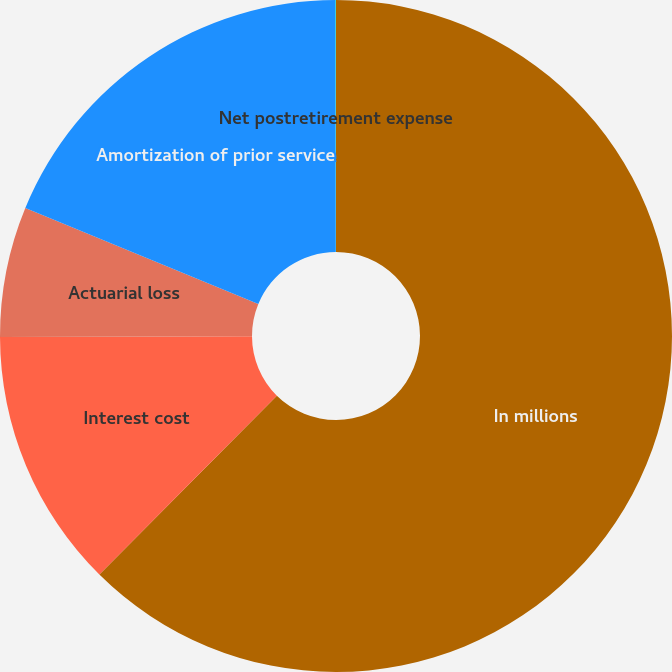Convert chart. <chart><loc_0><loc_0><loc_500><loc_500><pie_chart><fcel>In millions<fcel>Interest cost<fcel>Actuarial loss<fcel>Amortization of prior service<fcel>Net postretirement expense<nl><fcel>62.43%<fcel>12.51%<fcel>6.27%<fcel>18.75%<fcel>0.03%<nl></chart> 